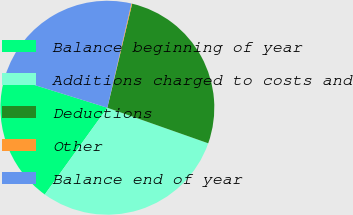Convert chart to OTSL. <chart><loc_0><loc_0><loc_500><loc_500><pie_chart><fcel>Balance beginning of year<fcel>Additions charged to costs and<fcel>Deductions<fcel>Other<fcel>Balance end of year<nl><fcel>19.87%<fcel>29.55%<fcel>26.67%<fcel>0.12%<fcel>23.79%<nl></chart> 